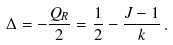Convert formula to latex. <formula><loc_0><loc_0><loc_500><loc_500>\Delta = - \frac { Q _ { R } } { 2 } = \frac { 1 } { 2 } - \frac { J - 1 } { k } \, .</formula> 